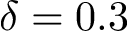Convert formula to latex. <formula><loc_0><loc_0><loc_500><loc_500>\delta = 0 . 3</formula> 